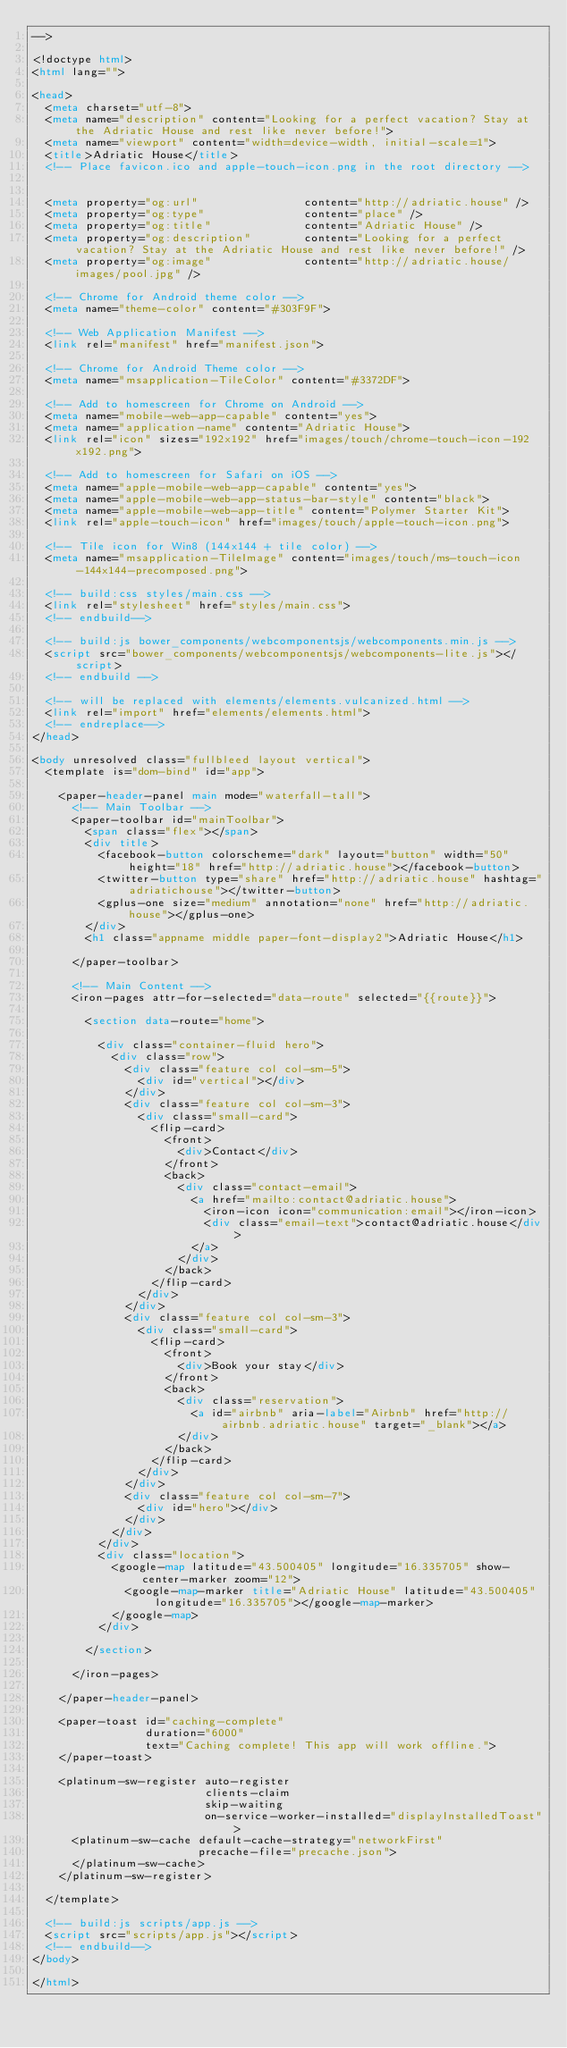<code> <loc_0><loc_0><loc_500><loc_500><_HTML_>-->

<!doctype html>
<html lang="">

<head>
  <meta charset="utf-8">
  <meta name="description" content="Looking for a perfect vacation? Stay at the Adriatic House and rest like never before!">
  <meta name="viewport" content="width=device-width, initial-scale=1">
  <title>Adriatic House</title>
  <!-- Place favicon.ico and apple-touch-icon.png in the root directory -->


  <meta property="og:url"                content="http://adriatic.house" />
  <meta property="og:type"               content="place" />
  <meta property="og:title"              content="Adriatic House" />
  <meta property="og:description"        content="Looking for a perfect vacation? Stay at the Adriatic House and rest like never before!" />
  <meta property="og:image"              content="http://adriatic.house/images/pool.jpg" />

  <!-- Chrome for Android theme color -->
  <meta name="theme-color" content="#303F9F">

  <!-- Web Application Manifest -->
  <link rel="manifest" href="manifest.json">

  <!-- Chrome for Android Theme color -->
  <meta name="msapplication-TileColor" content="#3372DF">

  <!-- Add to homescreen for Chrome on Android -->
  <meta name="mobile-web-app-capable" content="yes">
  <meta name="application-name" content="Adriatic House">
  <link rel="icon" sizes="192x192" href="images/touch/chrome-touch-icon-192x192.png">

  <!-- Add to homescreen for Safari on iOS -->
  <meta name="apple-mobile-web-app-capable" content="yes">
  <meta name="apple-mobile-web-app-status-bar-style" content="black">
  <meta name="apple-mobile-web-app-title" content="Polymer Starter Kit">
  <link rel="apple-touch-icon" href="images/touch/apple-touch-icon.png">

  <!-- Tile icon for Win8 (144x144 + tile color) -->
  <meta name="msapplication-TileImage" content="images/touch/ms-touch-icon-144x144-precomposed.png">

  <!-- build:css styles/main.css -->
  <link rel="stylesheet" href="styles/main.css">
  <!-- endbuild-->

  <!-- build:js bower_components/webcomponentsjs/webcomponents.min.js -->
  <script src="bower_components/webcomponentsjs/webcomponents-lite.js"></script>
  <!-- endbuild -->

  <!-- will be replaced with elements/elements.vulcanized.html -->
  <link rel="import" href="elements/elements.html">
  <!-- endreplace-->
</head>

<body unresolved class="fullbleed layout vertical">
  <template is="dom-bind" id="app">

    <paper-header-panel main mode="waterfall-tall">
      <!-- Main Toolbar -->
      <paper-toolbar id="mainToolbar">
        <span class="flex"></span>
        <div title>
          <facebook-button colorscheme="dark" layout="button" width="50" height="18" href="http://adriatic.house"></facebook-button>
          <twitter-button type="share" href="http://adriatic.house" hashtag="adriatichouse"></twitter-button>
          <gplus-one size="medium" annotation="none" href="http://adriatic.house"></gplus-one>
        </div>
        <h1 class="appname middle paper-font-display2">Adriatic House</h1>

      </paper-toolbar>

      <!-- Main Content -->
      <iron-pages attr-for-selected="data-route" selected="{{route}}">

        <section data-route="home">

          <div class="container-fluid hero">
            <div class="row">
              <div class="feature col col-sm-5">
                <div id="vertical"></div>
              </div>
              <div class="feature col col-sm-3">
                <div class="small-card">
                  <flip-card>
                    <front>
                      <div>Contact</div>
                    </front>
                    <back>
                      <div class="contact-email">
                        <a href="mailto:contact@adriatic.house">
                          <iron-icon icon="communication:email"></iron-icon>
                          <div class="email-text">contact@adriatic.house</div>
                        </a>
                      </div>
                    </back>
                  </flip-card>
                </div>
              </div>
              <div class="feature col col-sm-3">
                <div class="small-card">
                  <flip-card>
                    <front>
                      <div>Book your stay</div>
                    </front>
                    <back>
                      <div class="reservation">
                        <a id="airbnb" aria-label="Airbnb" href="http://airbnb.adriatic.house" target="_blank"></a>
                      </div>
                    </back>
                  </flip-card>
                </div>
              </div>
              <div class="feature col col-sm-7">
                <div id="hero"></div>
              </div>
            </div>
          </div>
          <div class="location">
            <google-map latitude="43.500405" longitude="16.335705" show-center-marker zoom="12">
              <google-map-marker title="Adriatic House" latitude="43.500405" longitude="16.335705"></google-map-marker>
            </google-map>
          </div>

        </section>

      </iron-pages>

    </paper-header-panel>

    <paper-toast id="caching-complete"
                 duration="6000"
                 text="Caching complete! This app will work offline.">
    </paper-toast>

    <platinum-sw-register auto-register
                          clients-claim
                          skip-waiting
                          on-service-worker-installed="displayInstalledToast">
      <platinum-sw-cache default-cache-strategy="networkFirst"
                         precache-file="precache.json">
      </platinum-sw-cache>
    </platinum-sw-register>

  </template>

  <!-- build:js scripts/app.js -->
  <script src="scripts/app.js"></script>
  <!-- endbuild-->
</body>

</html>
</code> 